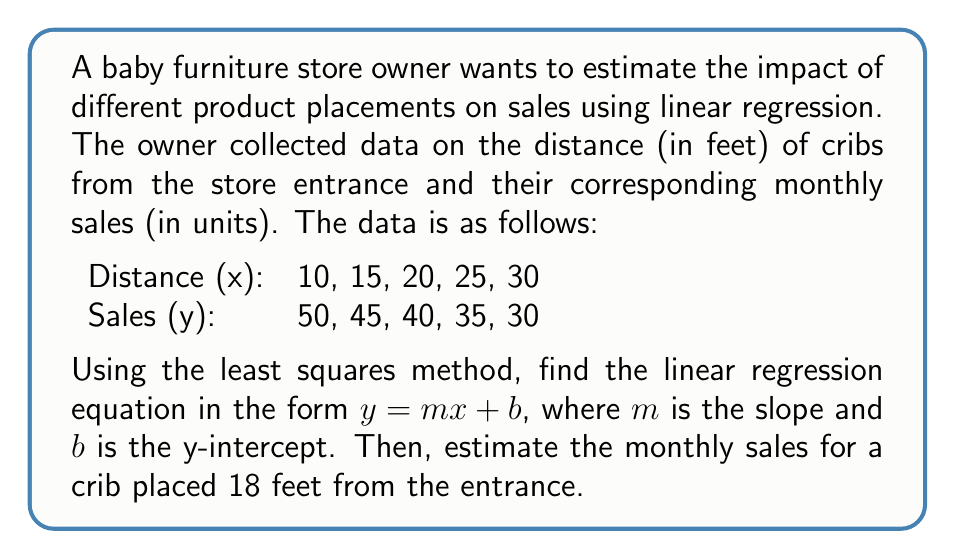Teach me how to tackle this problem. To find the linear regression equation using the least squares method, we need to calculate the slope $m$ and y-intercept $b$.

1. Calculate the means of x and y:
   $\bar{x} = \frac{10 + 15 + 20 + 25 + 30}{5} = 20$
   $\bar{y} = \frac{50 + 45 + 40 + 35 + 30}{5} = 40$

2. Calculate the slope $m$ using the formula:
   $$m = \frac{\sum (x_i - \bar{x})(y_i - \bar{y})}{\sum (x_i - \bar{x})^2}$$

   Create a table to calculate the necessary values:
   | $x_i$ | $y_i$ | $x_i - \bar{x}$ | $y_i - \bar{y}$ | $(x_i - \bar{x})(y_i - \bar{y})$ | $(x_i - \bar{x})^2$ |
   |-------|-------|-----------------|------------------|-----------------------------------|---------------------|
   | 10    | 50    | -10             | 10               | -100                              | 100                 |
   | 15    | 45    | -5              | 5                | -25                               | 25                  |
   | 20    | 40    | 0               | 0                | 0                                 | 0                   |
   | 25    | 35    | 5               | -5               | -25                               | 25                  |
   | 30    | 30    | 10              | -10              | -100                              | 100                 |
   | Sum   |       |                 |                  | -250                              | 250                 |

   Now, calculate the slope:
   $$m = \frac{-250}{250} = -1$$

3. Calculate the y-intercept $b$ using the formula:
   $$b = \bar{y} - m\bar{x}$$
   $$b = 40 - (-1)(20) = 60$$

4. The linear regression equation is:
   $$y = -x + 60$$

5. To estimate the monthly sales for a crib placed 18 feet from the entrance, substitute x = 18 into the equation:
   $$y = -18 + 60 = 42$$
Answer: The linear regression equation is $y = -x + 60$, and the estimated monthly sales for a crib placed 18 feet from the entrance is 42 units. 